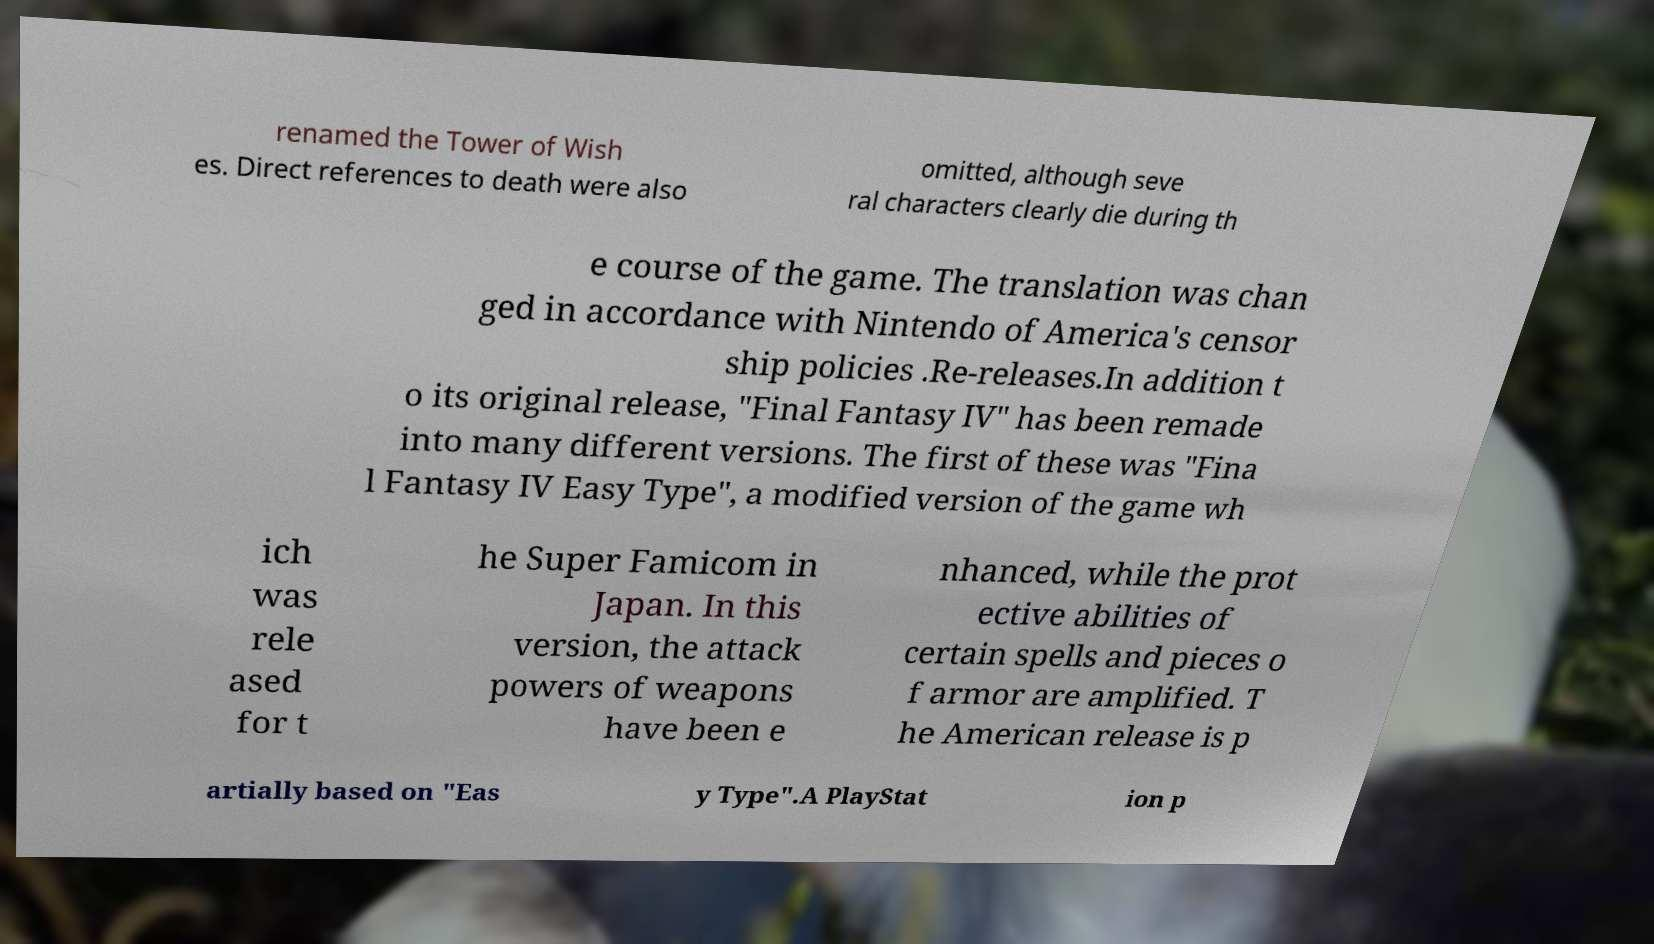I need the written content from this picture converted into text. Can you do that? renamed the Tower of Wish es. Direct references to death were also omitted, although seve ral characters clearly die during th e course of the game. The translation was chan ged in accordance with Nintendo of America's censor ship policies .Re-releases.In addition t o its original release, "Final Fantasy IV" has been remade into many different versions. The first of these was "Fina l Fantasy IV Easy Type", a modified version of the game wh ich was rele ased for t he Super Famicom in Japan. In this version, the attack powers of weapons have been e nhanced, while the prot ective abilities of certain spells and pieces o f armor are amplified. T he American release is p artially based on "Eas y Type".A PlayStat ion p 